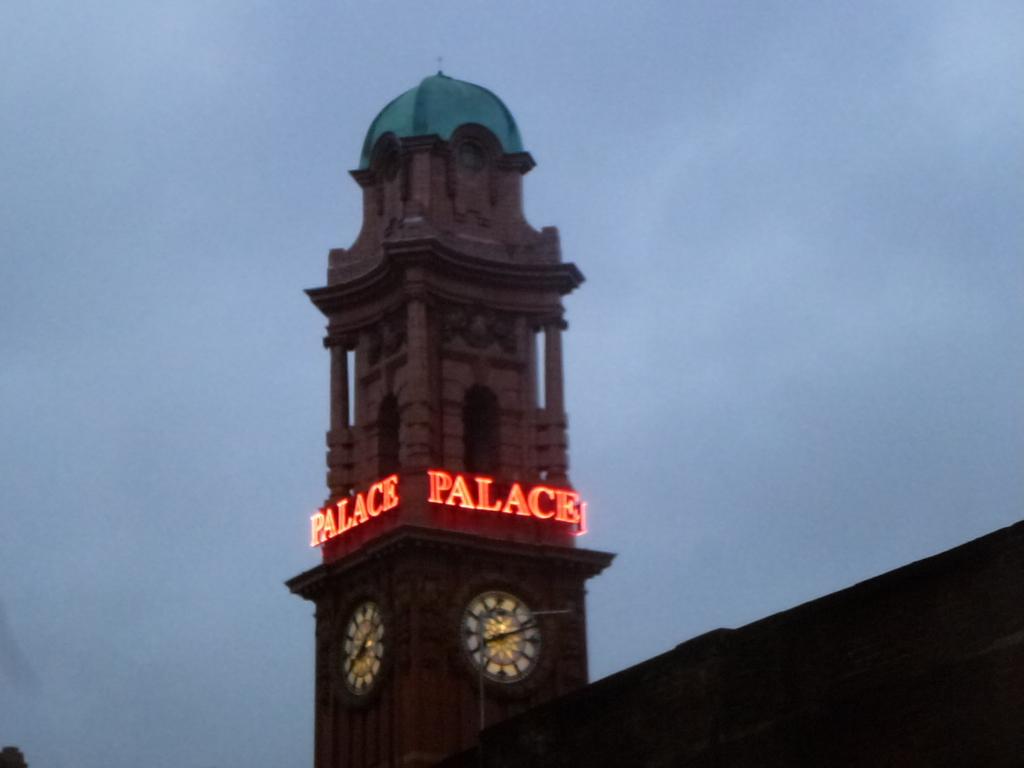What time does the clock say?
Your answer should be compact. 8:11. 